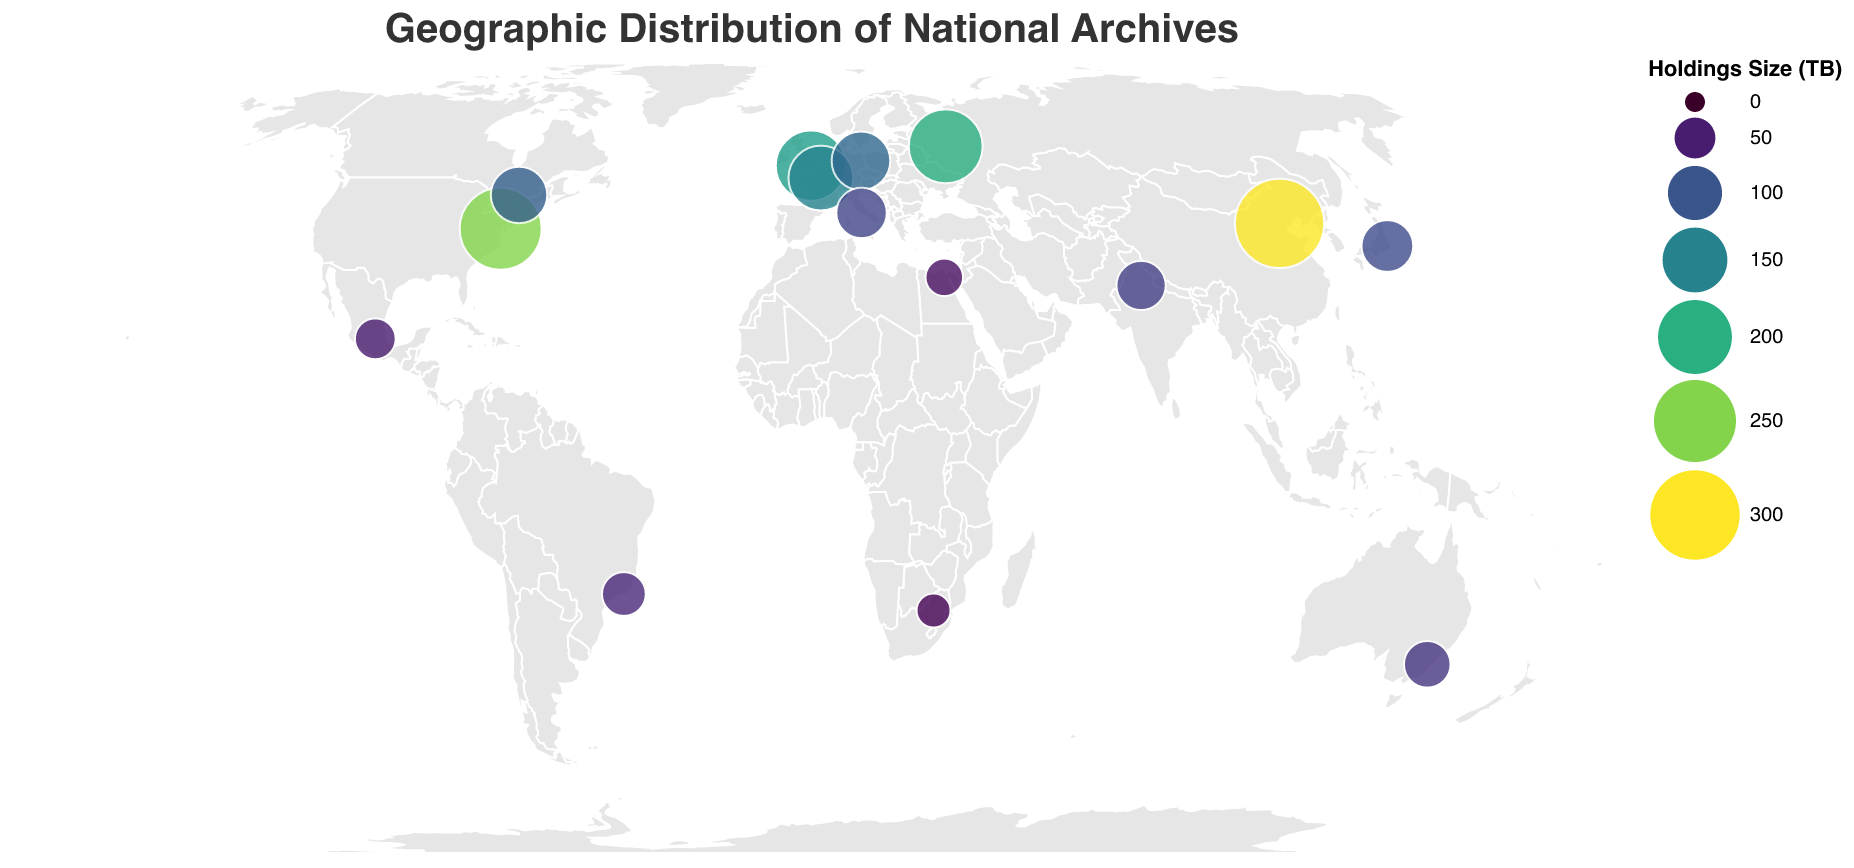what is the title of the figure? The title is located at the top of the figure, making it the most eye-catching and straightforward information.
Answer: Geographic Distribution of National Archives Which country has the largest archive holdings? The size of the circles represents the holdings size, and the largest circle indicates the country with the largest holdings.
Answer: China How many countries have archive holdings greater than 100 TB? By examining the size of the circles and the tooltip information for each country, we can count the number of countries with holdings greater than 100 TB.
Answer: 6 (USA, UK, France, Germany, Russia, China) Which country in the Southern Hemisphere has the largest archive holdings? Identifying countries in the Southern Hemisphere by their latitude and comparing the size of their circles, we find the largest one.
Answer: Australia What is the average size of archive holdings in Europe? (Assume UK, France, Germany, and Italy represent Europe) Sum the holdings of the European countries and divide by the number of these countries: (180 + 150 + 120 + 85) / 4 = 535 / 4.
Answer: 133.75 TB Compare the archive holdings between USA and Canada. By comparing the circle sizes and examining the numeric values from the tooltips, we see that USA has 250 TB while Canada has 110 TB.
Answer: USA has larger holdings than Canada Which archive is located at the highest latitude? The archive at the highest latitude will be the one positioned the furthest north. Using the provided latitudes, we find that Russia is the highest.
Answer: Russian State Archive What is the total archive holdings of the countries in the figure? Adding up all the holdings sizes from the tooltip data: 250 + 180 + 150 + 120 + 200 + 300 + 90 + 70 + 110 + 80 + 60 + 40 + 30 + 50 + 85.
Answer: 1815 TB Rank the top three countries by the size of their archive holdings. By examining and comparing the size of the circles and numeric values from the tooltips, the top three countries are China, USA, and Russia.
Answer: 1. China, 2. USA, 3. Russia Which country in Africa has national archives included in the plot, and what is their archive holding size? By identifying the countries by their latitudes and longitudes in Africa, we find the one with archive holdings mentioned in the figure.
Answer: South Africa, 30 TB 